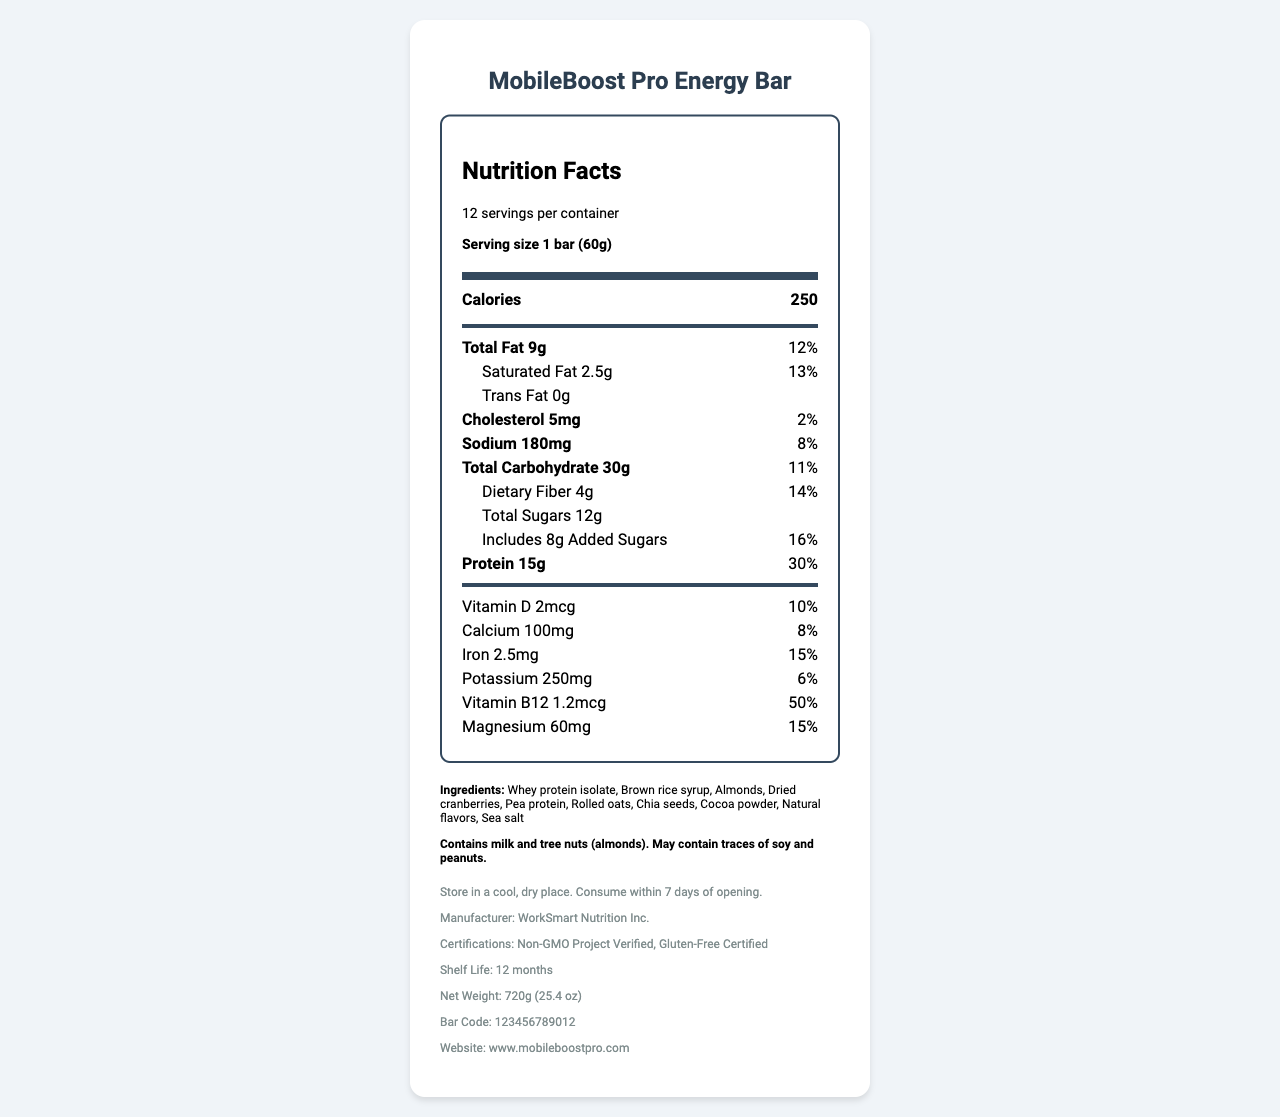What is the serving size of the MobileBoost Pro Energy Bar? The serving size is listed prominently in the serving information section of the nutrition facts.
Answer: 1 bar (60g) How many calories are in one serving of the MobileBoost Pro Energy Bar? The calories per serving are listed in the main information section.
Answer: 250 calories How much protein does one bar contain? The amount of protein per serving is indicated in the nutrient information section.
Answer: 15g What percentage of daily value does the total fat in one bar provide? The daily value percentage for total fat is listed next to its amount in the nutrient information section.
Answer: 12% What are the two certifications mentioned for the MobileBoost Pro Energy Bar? These certifications are listed in the additional information section at the bottom of the document.
Answer: Non-GMO Project Verified and Gluten-Free Certified How many grams of dietary fiber are in one serving? The amount of dietary fiber is specified in the nutrient information section.
Answer: 4g What are the ingredients in the MobileBoost Pro Energy Bar? These ingredients are listed under the ingredient section.
Answer: Whey protein isolate, Brown rice syrup, Almonds, Dried cranberries, Pea protein, Rolled oats, Chia seeds, Cocoa powder, Natural flavors, Sea salt What percentage of daily value does iron contribute? A. 10% B. 15% C. 20% The daily value percentage for iron is listed next to its amount in the section detailing various vitamins and minerals.
Answer: B. 15% Which of the following is not an ingredient in the MobileBoost Pro Energy Bar? 1. Dried cranberries 2. Chia seeds 3. Honey 4. Sea salt Honey is not listed among the ingredients in the document.
Answer: 3. Honey Does the MobileBoost Pro Energy Bar contain any trans fat? It is explicitly stated that the bar contains 0g trans fat in the nutrient information section.
Answer: No Summarize the main key points of the MobileBoost Pro Energy Bar's Nutrition Facts Label. This summary captures the main nutritional content, target audience, certifications, and key marketing claims present in the document.
Answer: The MobileBoost Pro Energy Bar is designed for the mobile workforce, providing 250 calories per serving, with 15g of protein and balanced macronutrients for sustained energy. It is Non-GMO and gluten-free, containing no artificial preservatives or flavors. The bar has useful vitamins and minerals and an allergen warning regarding milk and tree nuts. What is the contact email for WorkSmart Nutrition Inc.? The document provides a website but does not include an email address for contact.
Answer: Not enough information 